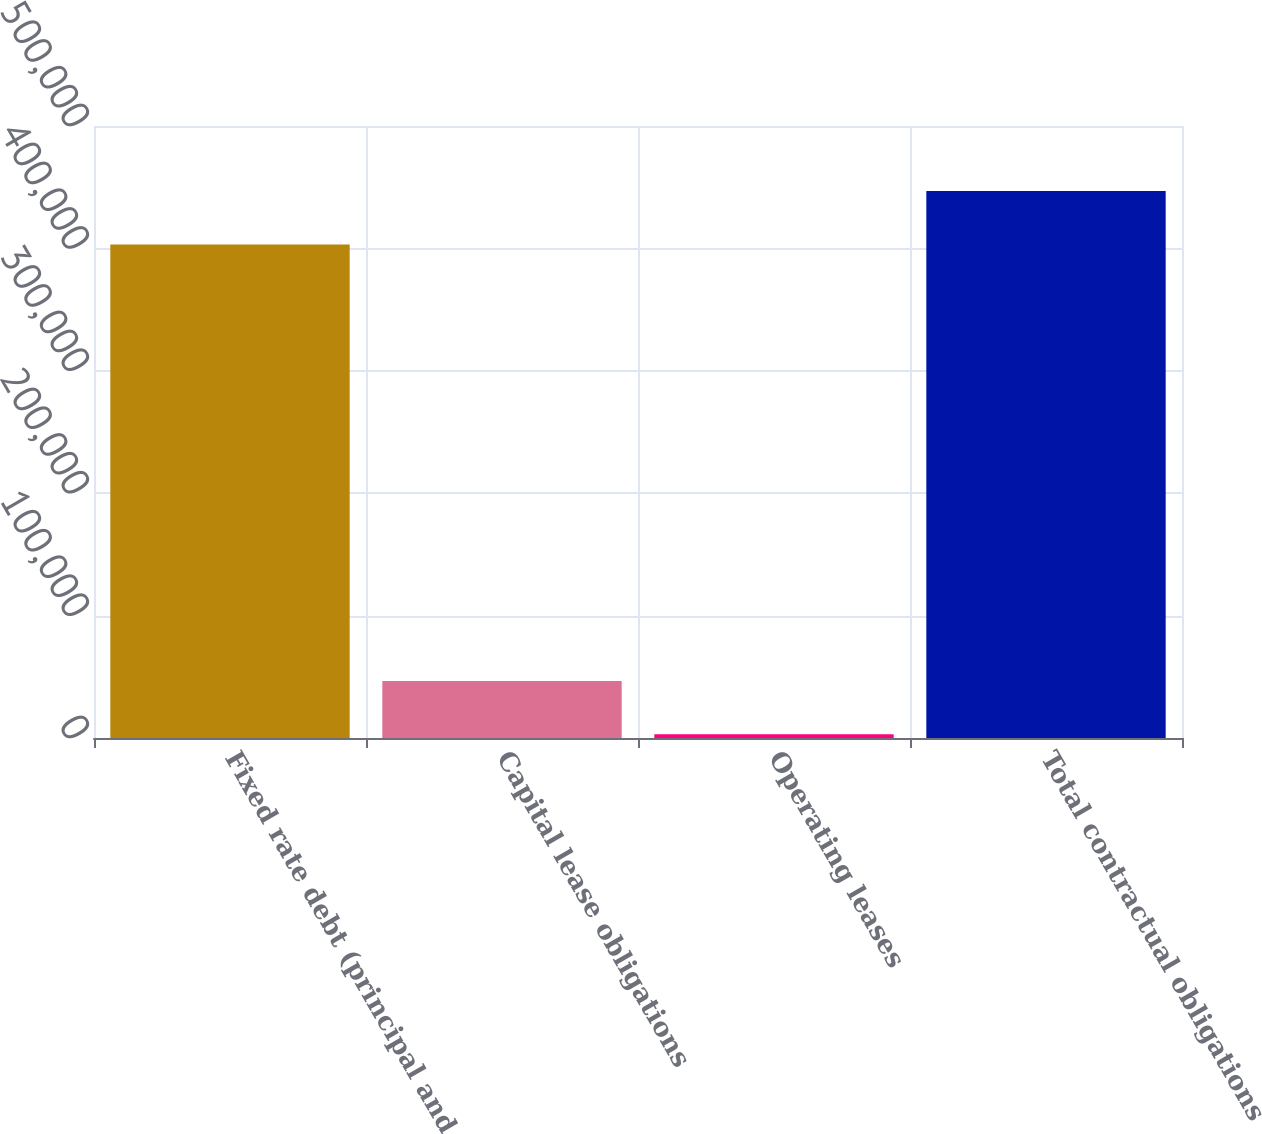<chart> <loc_0><loc_0><loc_500><loc_500><bar_chart><fcel>Fixed rate debt (principal and<fcel>Capital lease obligations<fcel>Operating leases<fcel>Total contractual obligations<nl><fcel>403245<fcel>46630.1<fcel>3063<fcel>446812<nl></chart> 